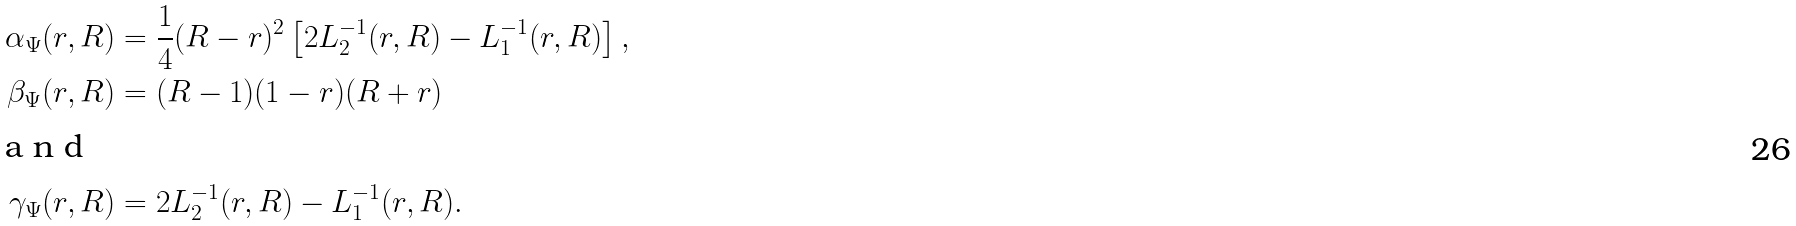Convert formula to latex. <formula><loc_0><loc_0><loc_500><loc_500>\alpha _ { \Psi } ( r , R ) & = \frac { 1 } { 4 } ( R - r ) ^ { 2 } \left [ { 2 L _ { 2 } ^ { - 1 } ( r , R ) - L _ { 1 } ^ { - 1 } ( r , R ) } \right ] , \\ \beta _ { \Psi } ( r , R ) & = ( R - 1 ) ( 1 - r ) ( R + r ) \\ \intertext { a n d } \gamma _ { \Psi } ( r , R ) & = 2 L _ { 2 } ^ { - 1 } ( r , R ) - L _ { 1 } ^ { - 1 } ( r , R ) .</formula> 